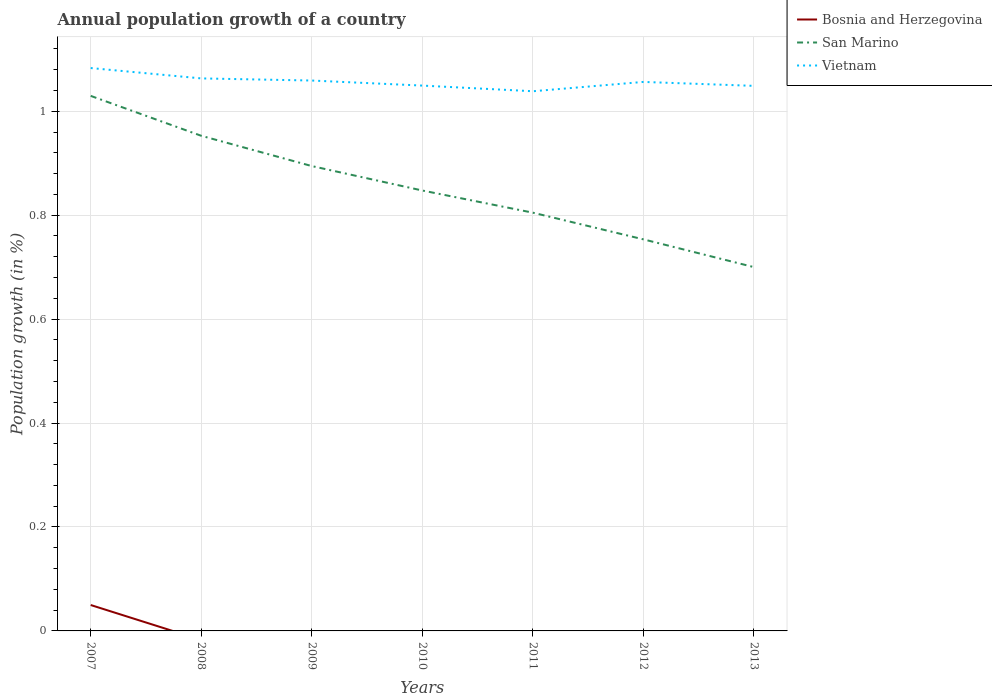Does the line corresponding to Vietnam intersect with the line corresponding to Bosnia and Herzegovina?
Your answer should be compact. No. Is the number of lines equal to the number of legend labels?
Provide a succinct answer. No. What is the total annual population growth in Vietnam in the graph?
Offer a very short reply. 0.02. What is the difference between the highest and the second highest annual population growth in San Marino?
Your answer should be compact. 0.33. What is the difference between the highest and the lowest annual population growth in Bosnia and Herzegovina?
Offer a very short reply. 1. Is the annual population growth in Vietnam strictly greater than the annual population growth in San Marino over the years?
Provide a succinct answer. No. How many lines are there?
Offer a very short reply. 3. How many years are there in the graph?
Offer a terse response. 7. How are the legend labels stacked?
Ensure brevity in your answer.  Vertical. What is the title of the graph?
Give a very brief answer. Annual population growth of a country. What is the label or title of the X-axis?
Give a very brief answer. Years. What is the label or title of the Y-axis?
Give a very brief answer. Population growth (in %). What is the Population growth (in %) of Bosnia and Herzegovina in 2007?
Ensure brevity in your answer.  0.05. What is the Population growth (in %) of San Marino in 2007?
Keep it short and to the point. 1.03. What is the Population growth (in %) of Vietnam in 2007?
Give a very brief answer. 1.08. What is the Population growth (in %) of San Marino in 2008?
Your answer should be compact. 0.95. What is the Population growth (in %) of Vietnam in 2008?
Your answer should be compact. 1.06. What is the Population growth (in %) in Bosnia and Herzegovina in 2009?
Your answer should be compact. 0. What is the Population growth (in %) in San Marino in 2009?
Give a very brief answer. 0.89. What is the Population growth (in %) in Vietnam in 2009?
Provide a short and direct response. 1.06. What is the Population growth (in %) in Bosnia and Herzegovina in 2010?
Make the answer very short. 0. What is the Population growth (in %) in San Marino in 2010?
Keep it short and to the point. 0.85. What is the Population growth (in %) of Vietnam in 2010?
Your response must be concise. 1.05. What is the Population growth (in %) of San Marino in 2011?
Ensure brevity in your answer.  0.8. What is the Population growth (in %) in Vietnam in 2011?
Provide a short and direct response. 1.04. What is the Population growth (in %) of Bosnia and Herzegovina in 2012?
Offer a terse response. 0. What is the Population growth (in %) of San Marino in 2012?
Keep it short and to the point. 0.75. What is the Population growth (in %) in Vietnam in 2012?
Offer a terse response. 1.06. What is the Population growth (in %) of Bosnia and Herzegovina in 2013?
Your answer should be compact. 0. What is the Population growth (in %) in San Marino in 2013?
Your answer should be very brief. 0.7. What is the Population growth (in %) of Vietnam in 2013?
Provide a succinct answer. 1.05. Across all years, what is the maximum Population growth (in %) in Bosnia and Herzegovina?
Offer a terse response. 0.05. Across all years, what is the maximum Population growth (in %) of San Marino?
Provide a short and direct response. 1.03. Across all years, what is the maximum Population growth (in %) of Vietnam?
Make the answer very short. 1.08. Across all years, what is the minimum Population growth (in %) in Bosnia and Herzegovina?
Provide a succinct answer. 0. Across all years, what is the minimum Population growth (in %) in San Marino?
Your response must be concise. 0.7. Across all years, what is the minimum Population growth (in %) in Vietnam?
Your answer should be very brief. 1.04. What is the total Population growth (in %) in Bosnia and Herzegovina in the graph?
Ensure brevity in your answer.  0.05. What is the total Population growth (in %) in San Marino in the graph?
Ensure brevity in your answer.  5.98. What is the total Population growth (in %) in Vietnam in the graph?
Your answer should be compact. 7.4. What is the difference between the Population growth (in %) of San Marino in 2007 and that in 2008?
Provide a succinct answer. 0.08. What is the difference between the Population growth (in %) in Vietnam in 2007 and that in 2008?
Offer a very short reply. 0.02. What is the difference between the Population growth (in %) of San Marino in 2007 and that in 2009?
Give a very brief answer. 0.14. What is the difference between the Population growth (in %) of Vietnam in 2007 and that in 2009?
Your answer should be compact. 0.02. What is the difference between the Population growth (in %) of San Marino in 2007 and that in 2010?
Offer a terse response. 0.18. What is the difference between the Population growth (in %) in Vietnam in 2007 and that in 2010?
Your answer should be compact. 0.03. What is the difference between the Population growth (in %) of San Marino in 2007 and that in 2011?
Make the answer very short. 0.22. What is the difference between the Population growth (in %) in Vietnam in 2007 and that in 2011?
Your answer should be very brief. 0.04. What is the difference between the Population growth (in %) in San Marino in 2007 and that in 2012?
Your response must be concise. 0.28. What is the difference between the Population growth (in %) of Vietnam in 2007 and that in 2012?
Ensure brevity in your answer.  0.03. What is the difference between the Population growth (in %) of San Marino in 2007 and that in 2013?
Give a very brief answer. 0.33. What is the difference between the Population growth (in %) in Vietnam in 2007 and that in 2013?
Your answer should be very brief. 0.03. What is the difference between the Population growth (in %) of San Marino in 2008 and that in 2009?
Your answer should be very brief. 0.06. What is the difference between the Population growth (in %) in Vietnam in 2008 and that in 2009?
Your answer should be very brief. 0. What is the difference between the Population growth (in %) of San Marino in 2008 and that in 2010?
Offer a very short reply. 0.11. What is the difference between the Population growth (in %) in Vietnam in 2008 and that in 2010?
Give a very brief answer. 0.01. What is the difference between the Population growth (in %) of San Marino in 2008 and that in 2011?
Your response must be concise. 0.15. What is the difference between the Population growth (in %) in Vietnam in 2008 and that in 2011?
Offer a terse response. 0.02. What is the difference between the Population growth (in %) in San Marino in 2008 and that in 2012?
Provide a succinct answer. 0.2. What is the difference between the Population growth (in %) in Vietnam in 2008 and that in 2012?
Offer a terse response. 0.01. What is the difference between the Population growth (in %) in San Marino in 2008 and that in 2013?
Offer a terse response. 0.25. What is the difference between the Population growth (in %) in Vietnam in 2008 and that in 2013?
Offer a very short reply. 0.01. What is the difference between the Population growth (in %) in San Marino in 2009 and that in 2010?
Give a very brief answer. 0.05. What is the difference between the Population growth (in %) of Vietnam in 2009 and that in 2010?
Provide a short and direct response. 0.01. What is the difference between the Population growth (in %) in San Marino in 2009 and that in 2011?
Give a very brief answer. 0.09. What is the difference between the Population growth (in %) in Vietnam in 2009 and that in 2011?
Ensure brevity in your answer.  0.02. What is the difference between the Population growth (in %) of San Marino in 2009 and that in 2012?
Give a very brief answer. 0.14. What is the difference between the Population growth (in %) of Vietnam in 2009 and that in 2012?
Your answer should be very brief. 0. What is the difference between the Population growth (in %) in San Marino in 2009 and that in 2013?
Your answer should be very brief. 0.19. What is the difference between the Population growth (in %) in Vietnam in 2009 and that in 2013?
Your answer should be compact. 0.01. What is the difference between the Population growth (in %) in San Marino in 2010 and that in 2011?
Your answer should be very brief. 0.04. What is the difference between the Population growth (in %) in Vietnam in 2010 and that in 2011?
Your response must be concise. 0.01. What is the difference between the Population growth (in %) of San Marino in 2010 and that in 2012?
Offer a terse response. 0.09. What is the difference between the Population growth (in %) in Vietnam in 2010 and that in 2012?
Keep it short and to the point. -0.01. What is the difference between the Population growth (in %) in San Marino in 2010 and that in 2013?
Give a very brief answer. 0.15. What is the difference between the Population growth (in %) in Vietnam in 2010 and that in 2013?
Keep it short and to the point. 0. What is the difference between the Population growth (in %) in San Marino in 2011 and that in 2012?
Your answer should be compact. 0.05. What is the difference between the Population growth (in %) in Vietnam in 2011 and that in 2012?
Provide a short and direct response. -0.02. What is the difference between the Population growth (in %) in San Marino in 2011 and that in 2013?
Provide a succinct answer. 0.1. What is the difference between the Population growth (in %) of Vietnam in 2011 and that in 2013?
Offer a terse response. -0.01. What is the difference between the Population growth (in %) in San Marino in 2012 and that in 2013?
Make the answer very short. 0.05. What is the difference between the Population growth (in %) in Vietnam in 2012 and that in 2013?
Provide a short and direct response. 0.01. What is the difference between the Population growth (in %) of Bosnia and Herzegovina in 2007 and the Population growth (in %) of San Marino in 2008?
Offer a very short reply. -0.9. What is the difference between the Population growth (in %) in Bosnia and Herzegovina in 2007 and the Population growth (in %) in Vietnam in 2008?
Keep it short and to the point. -1.01. What is the difference between the Population growth (in %) of San Marino in 2007 and the Population growth (in %) of Vietnam in 2008?
Your response must be concise. -0.03. What is the difference between the Population growth (in %) in Bosnia and Herzegovina in 2007 and the Population growth (in %) in San Marino in 2009?
Your response must be concise. -0.84. What is the difference between the Population growth (in %) in Bosnia and Herzegovina in 2007 and the Population growth (in %) in Vietnam in 2009?
Your response must be concise. -1.01. What is the difference between the Population growth (in %) in San Marino in 2007 and the Population growth (in %) in Vietnam in 2009?
Your answer should be compact. -0.03. What is the difference between the Population growth (in %) in Bosnia and Herzegovina in 2007 and the Population growth (in %) in San Marino in 2010?
Offer a very short reply. -0.8. What is the difference between the Population growth (in %) of Bosnia and Herzegovina in 2007 and the Population growth (in %) of Vietnam in 2010?
Make the answer very short. -1. What is the difference between the Population growth (in %) in San Marino in 2007 and the Population growth (in %) in Vietnam in 2010?
Make the answer very short. -0.02. What is the difference between the Population growth (in %) of Bosnia and Herzegovina in 2007 and the Population growth (in %) of San Marino in 2011?
Make the answer very short. -0.76. What is the difference between the Population growth (in %) in Bosnia and Herzegovina in 2007 and the Population growth (in %) in Vietnam in 2011?
Make the answer very short. -0.99. What is the difference between the Population growth (in %) of San Marino in 2007 and the Population growth (in %) of Vietnam in 2011?
Make the answer very short. -0.01. What is the difference between the Population growth (in %) of Bosnia and Herzegovina in 2007 and the Population growth (in %) of San Marino in 2012?
Your answer should be compact. -0.7. What is the difference between the Population growth (in %) in Bosnia and Herzegovina in 2007 and the Population growth (in %) in Vietnam in 2012?
Your response must be concise. -1.01. What is the difference between the Population growth (in %) of San Marino in 2007 and the Population growth (in %) of Vietnam in 2012?
Your response must be concise. -0.03. What is the difference between the Population growth (in %) in Bosnia and Herzegovina in 2007 and the Population growth (in %) in San Marino in 2013?
Provide a short and direct response. -0.65. What is the difference between the Population growth (in %) of Bosnia and Herzegovina in 2007 and the Population growth (in %) of Vietnam in 2013?
Offer a very short reply. -1. What is the difference between the Population growth (in %) in San Marino in 2007 and the Population growth (in %) in Vietnam in 2013?
Your response must be concise. -0.02. What is the difference between the Population growth (in %) of San Marino in 2008 and the Population growth (in %) of Vietnam in 2009?
Your answer should be compact. -0.11. What is the difference between the Population growth (in %) in San Marino in 2008 and the Population growth (in %) in Vietnam in 2010?
Your answer should be very brief. -0.1. What is the difference between the Population growth (in %) of San Marino in 2008 and the Population growth (in %) of Vietnam in 2011?
Your response must be concise. -0.09. What is the difference between the Population growth (in %) in San Marino in 2008 and the Population growth (in %) in Vietnam in 2012?
Keep it short and to the point. -0.1. What is the difference between the Population growth (in %) in San Marino in 2008 and the Population growth (in %) in Vietnam in 2013?
Ensure brevity in your answer.  -0.1. What is the difference between the Population growth (in %) of San Marino in 2009 and the Population growth (in %) of Vietnam in 2010?
Keep it short and to the point. -0.15. What is the difference between the Population growth (in %) of San Marino in 2009 and the Population growth (in %) of Vietnam in 2011?
Make the answer very short. -0.14. What is the difference between the Population growth (in %) in San Marino in 2009 and the Population growth (in %) in Vietnam in 2012?
Offer a very short reply. -0.16. What is the difference between the Population growth (in %) in San Marino in 2009 and the Population growth (in %) in Vietnam in 2013?
Keep it short and to the point. -0.15. What is the difference between the Population growth (in %) of San Marino in 2010 and the Population growth (in %) of Vietnam in 2011?
Your answer should be very brief. -0.19. What is the difference between the Population growth (in %) of San Marino in 2010 and the Population growth (in %) of Vietnam in 2012?
Your response must be concise. -0.21. What is the difference between the Population growth (in %) in San Marino in 2010 and the Population growth (in %) in Vietnam in 2013?
Your answer should be very brief. -0.2. What is the difference between the Population growth (in %) in San Marino in 2011 and the Population growth (in %) in Vietnam in 2012?
Offer a very short reply. -0.25. What is the difference between the Population growth (in %) of San Marino in 2011 and the Population growth (in %) of Vietnam in 2013?
Offer a very short reply. -0.24. What is the difference between the Population growth (in %) of San Marino in 2012 and the Population growth (in %) of Vietnam in 2013?
Your answer should be compact. -0.3. What is the average Population growth (in %) of Bosnia and Herzegovina per year?
Your answer should be very brief. 0.01. What is the average Population growth (in %) in San Marino per year?
Provide a short and direct response. 0.85. What is the average Population growth (in %) of Vietnam per year?
Give a very brief answer. 1.06. In the year 2007, what is the difference between the Population growth (in %) in Bosnia and Herzegovina and Population growth (in %) in San Marino?
Keep it short and to the point. -0.98. In the year 2007, what is the difference between the Population growth (in %) in Bosnia and Herzegovina and Population growth (in %) in Vietnam?
Keep it short and to the point. -1.03. In the year 2007, what is the difference between the Population growth (in %) of San Marino and Population growth (in %) of Vietnam?
Provide a short and direct response. -0.05. In the year 2008, what is the difference between the Population growth (in %) of San Marino and Population growth (in %) of Vietnam?
Give a very brief answer. -0.11. In the year 2009, what is the difference between the Population growth (in %) in San Marino and Population growth (in %) in Vietnam?
Offer a terse response. -0.16. In the year 2010, what is the difference between the Population growth (in %) of San Marino and Population growth (in %) of Vietnam?
Your response must be concise. -0.2. In the year 2011, what is the difference between the Population growth (in %) of San Marino and Population growth (in %) of Vietnam?
Give a very brief answer. -0.23. In the year 2012, what is the difference between the Population growth (in %) of San Marino and Population growth (in %) of Vietnam?
Make the answer very short. -0.3. In the year 2013, what is the difference between the Population growth (in %) in San Marino and Population growth (in %) in Vietnam?
Make the answer very short. -0.35. What is the ratio of the Population growth (in %) of San Marino in 2007 to that in 2008?
Your answer should be compact. 1.08. What is the ratio of the Population growth (in %) of Vietnam in 2007 to that in 2008?
Offer a terse response. 1.02. What is the ratio of the Population growth (in %) in San Marino in 2007 to that in 2009?
Offer a terse response. 1.15. What is the ratio of the Population growth (in %) of Vietnam in 2007 to that in 2009?
Make the answer very short. 1.02. What is the ratio of the Population growth (in %) in San Marino in 2007 to that in 2010?
Your response must be concise. 1.21. What is the ratio of the Population growth (in %) in Vietnam in 2007 to that in 2010?
Ensure brevity in your answer.  1.03. What is the ratio of the Population growth (in %) of San Marino in 2007 to that in 2011?
Your answer should be compact. 1.28. What is the ratio of the Population growth (in %) of Vietnam in 2007 to that in 2011?
Ensure brevity in your answer.  1.04. What is the ratio of the Population growth (in %) of San Marino in 2007 to that in 2012?
Your answer should be very brief. 1.37. What is the ratio of the Population growth (in %) of Vietnam in 2007 to that in 2012?
Your answer should be compact. 1.03. What is the ratio of the Population growth (in %) of San Marino in 2007 to that in 2013?
Offer a very short reply. 1.47. What is the ratio of the Population growth (in %) in Vietnam in 2007 to that in 2013?
Provide a short and direct response. 1.03. What is the ratio of the Population growth (in %) of San Marino in 2008 to that in 2009?
Provide a succinct answer. 1.07. What is the ratio of the Population growth (in %) in San Marino in 2008 to that in 2010?
Offer a terse response. 1.12. What is the ratio of the Population growth (in %) in Vietnam in 2008 to that in 2010?
Your response must be concise. 1.01. What is the ratio of the Population growth (in %) of San Marino in 2008 to that in 2011?
Your answer should be compact. 1.18. What is the ratio of the Population growth (in %) of Vietnam in 2008 to that in 2011?
Your answer should be very brief. 1.02. What is the ratio of the Population growth (in %) of San Marino in 2008 to that in 2012?
Keep it short and to the point. 1.26. What is the ratio of the Population growth (in %) of Vietnam in 2008 to that in 2012?
Give a very brief answer. 1.01. What is the ratio of the Population growth (in %) in San Marino in 2008 to that in 2013?
Offer a terse response. 1.36. What is the ratio of the Population growth (in %) in Vietnam in 2008 to that in 2013?
Give a very brief answer. 1.01. What is the ratio of the Population growth (in %) in San Marino in 2009 to that in 2010?
Offer a very short reply. 1.06. What is the ratio of the Population growth (in %) of Vietnam in 2009 to that in 2010?
Provide a succinct answer. 1.01. What is the ratio of the Population growth (in %) in San Marino in 2009 to that in 2011?
Give a very brief answer. 1.11. What is the ratio of the Population growth (in %) of Vietnam in 2009 to that in 2011?
Give a very brief answer. 1.02. What is the ratio of the Population growth (in %) of San Marino in 2009 to that in 2012?
Provide a short and direct response. 1.19. What is the ratio of the Population growth (in %) in Vietnam in 2009 to that in 2012?
Ensure brevity in your answer.  1. What is the ratio of the Population growth (in %) of San Marino in 2009 to that in 2013?
Offer a very short reply. 1.28. What is the ratio of the Population growth (in %) of Vietnam in 2009 to that in 2013?
Your response must be concise. 1.01. What is the ratio of the Population growth (in %) of San Marino in 2010 to that in 2011?
Provide a succinct answer. 1.05. What is the ratio of the Population growth (in %) in Vietnam in 2010 to that in 2011?
Keep it short and to the point. 1.01. What is the ratio of the Population growth (in %) in San Marino in 2010 to that in 2012?
Give a very brief answer. 1.12. What is the ratio of the Population growth (in %) in San Marino in 2010 to that in 2013?
Provide a short and direct response. 1.21. What is the ratio of the Population growth (in %) of Vietnam in 2010 to that in 2013?
Make the answer very short. 1. What is the ratio of the Population growth (in %) in San Marino in 2011 to that in 2012?
Offer a terse response. 1.07. What is the ratio of the Population growth (in %) in Vietnam in 2011 to that in 2012?
Make the answer very short. 0.98. What is the ratio of the Population growth (in %) in San Marino in 2011 to that in 2013?
Your answer should be very brief. 1.15. What is the ratio of the Population growth (in %) in San Marino in 2012 to that in 2013?
Provide a short and direct response. 1.08. What is the ratio of the Population growth (in %) in Vietnam in 2012 to that in 2013?
Keep it short and to the point. 1.01. What is the difference between the highest and the second highest Population growth (in %) of San Marino?
Your answer should be compact. 0.08. What is the difference between the highest and the second highest Population growth (in %) of Vietnam?
Provide a short and direct response. 0.02. What is the difference between the highest and the lowest Population growth (in %) of Bosnia and Herzegovina?
Give a very brief answer. 0.05. What is the difference between the highest and the lowest Population growth (in %) in San Marino?
Make the answer very short. 0.33. What is the difference between the highest and the lowest Population growth (in %) in Vietnam?
Your response must be concise. 0.04. 